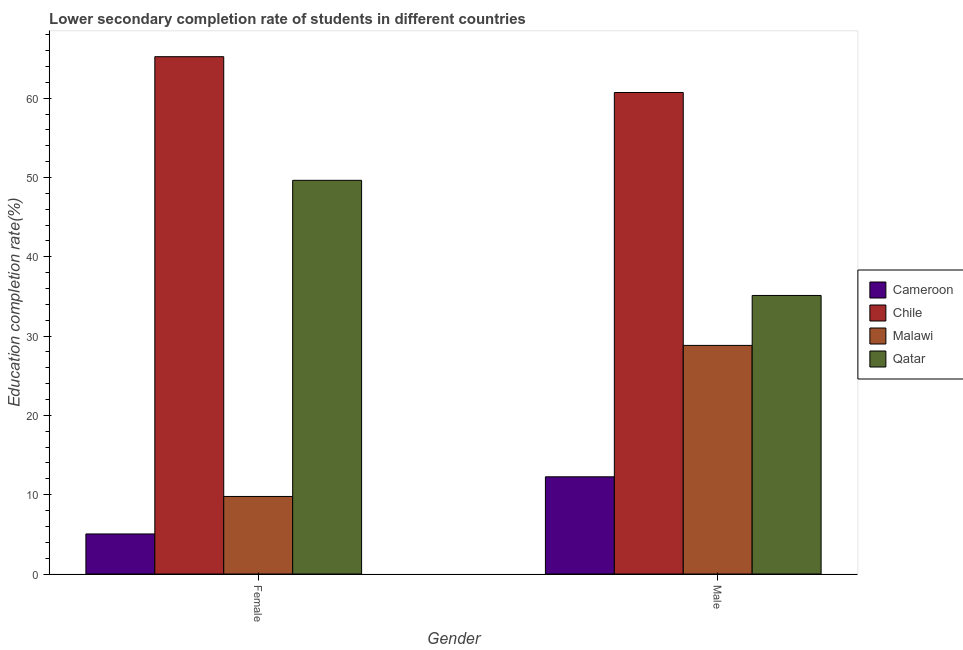Are the number of bars per tick equal to the number of legend labels?
Offer a terse response. Yes. Are the number of bars on each tick of the X-axis equal?
Ensure brevity in your answer.  Yes. How many bars are there on the 1st tick from the right?
Offer a very short reply. 4. What is the education completion rate of female students in Qatar?
Your answer should be compact. 49.64. Across all countries, what is the maximum education completion rate of female students?
Your answer should be very brief. 65.23. Across all countries, what is the minimum education completion rate of male students?
Ensure brevity in your answer.  12.26. In which country was the education completion rate of male students maximum?
Keep it short and to the point. Chile. In which country was the education completion rate of female students minimum?
Provide a succinct answer. Cameroon. What is the total education completion rate of male students in the graph?
Give a very brief answer. 136.91. What is the difference between the education completion rate of female students in Cameroon and that in Qatar?
Make the answer very short. -44.59. What is the difference between the education completion rate of male students in Malawi and the education completion rate of female students in Cameroon?
Ensure brevity in your answer.  23.77. What is the average education completion rate of male students per country?
Your answer should be very brief. 34.23. What is the difference between the education completion rate of male students and education completion rate of female students in Malawi?
Make the answer very short. 19.05. In how many countries, is the education completion rate of female students greater than 22 %?
Provide a short and direct response. 2. What is the ratio of the education completion rate of male students in Qatar to that in Cameroon?
Ensure brevity in your answer.  2.87. Is the education completion rate of female students in Malawi less than that in Qatar?
Your answer should be compact. Yes. What does the 4th bar from the left in Female represents?
Offer a very short reply. Qatar. What does the 3rd bar from the right in Female represents?
Provide a succinct answer. Chile. How many bars are there?
Make the answer very short. 8. Are all the bars in the graph horizontal?
Provide a succinct answer. No. Does the graph contain any zero values?
Ensure brevity in your answer.  No. Does the graph contain grids?
Your answer should be very brief. No. Where does the legend appear in the graph?
Your response must be concise. Center right. What is the title of the graph?
Provide a succinct answer. Lower secondary completion rate of students in different countries. What is the label or title of the Y-axis?
Make the answer very short. Education completion rate(%). What is the Education completion rate(%) of Cameroon in Female?
Give a very brief answer. 5.05. What is the Education completion rate(%) in Chile in Female?
Your answer should be compact. 65.23. What is the Education completion rate(%) in Malawi in Female?
Provide a short and direct response. 9.78. What is the Education completion rate(%) of Qatar in Female?
Your response must be concise. 49.64. What is the Education completion rate(%) in Cameroon in Male?
Make the answer very short. 12.26. What is the Education completion rate(%) of Chile in Male?
Make the answer very short. 60.71. What is the Education completion rate(%) in Malawi in Male?
Make the answer very short. 28.82. What is the Education completion rate(%) of Qatar in Male?
Offer a terse response. 35.12. Across all Gender, what is the maximum Education completion rate(%) in Cameroon?
Give a very brief answer. 12.26. Across all Gender, what is the maximum Education completion rate(%) in Chile?
Your answer should be very brief. 65.23. Across all Gender, what is the maximum Education completion rate(%) in Malawi?
Provide a succinct answer. 28.82. Across all Gender, what is the maximum Education completion rate(%) of Qatar?
Provide a short and direct response. 49.64. Across all Gender, what is the minimum Education completion rate(%) of Cameroon?
Offer a very short reply. 5.05. Across all Gender, what is the minimum Education completion rate(%) of Chile?
Your answer should be compact. 60.71. Across all Gender, what is the minimum Education completion rate(%) of Malawi?
Your response must be concise. 9.78. Across all Gender, what is the minimum Education completion rate(%) in Qatar?
Your answer should be compact. 35.12. What is the total Education completion rate(%) of Cameroon in the graph?
Offer a terse response. 17.31. What is the total Education completion rate(%) of Chile in the graph?
Your answer should be compact. 125.94. What is the total Education completion rate(%) in Malawi in the graph?
Keep it short and to the point. 38.6. What is the total Education completion rate(%) in Qatar in the graph?
Your answer should be compact. 84.76. What is the difference between the Education completion rate(%) of Cameroon in Female and that in Male?
Your answer should be very brief. -7.21. What is the difference between the Education completion rate(%) in Chile in Female and that in Male?
Offer a very short reply. 4.52. What is the difference between the Education completion rate(%) of Malawi in Female and that in Male?
Offer a very short reply. -19.05. What is the difference between the Education completion rate(%) of Qatar in Female and that in Male?
Offer a terse response. 14.52. What is the difference between the Education completion rate(%) of Cameroon in Female and the Education completion rate(%) of Chile in Male?
Your response must be concise. -55.66. What is the difference between the Education completion rate(%) in Cameroon in Female and the Education completion rate(%) in Malawi in Male?
Your answer should be very brief. -23.77. What is the difference between the Education completion rate(%) of Cameroon in Female and the Education completion rate(%) of Qatar in Male?
Ensure brevity in your answer.  -30.07. What is the difference between the Education completion rate(%) of Chile in Female and the Education completion rate(%) of Malawi in Male?
Give a very brief answer. 36.4. What is the difference between the Education completion rate(%) of Chile in Female and the Education completion rate(%) of Qatar in Male?
Make the answer very short. 30.11. What is the difference between the Education completion rate(%) in Malawi in Female and the Education completion rate(%) in Qatar in Male?
Provide a succinct answer. -25.34. What is the average Education completion rate(%) in Cameroon per Gender?
Provide a short and direct response. 8.65. What is the average Education completion rate(%) in Chile per Gender?
Offer a terse response. 62.97. What is the average Education completion rate(%) of Malawi per Gender?
Give a very brief answer. 19.3. What is the average Education completion rate(%) of Qatar per Gender?
Ensure brevity in your answer.  42.38. What is the difference between the Education completion rate(%) of Cameroon and Education completion rate(%) of Chile in Female?
Keep it short and to the point. -60.18. What is the difference between the Education completion rate(%) of Cameroon and Education completion rate(%) of Malawi in Female?
Make the answer very short. -4.73. What is the difference between the Education completion rate(%) of Cameroon and Education completion rate(%) of Qatar in Female?
Provide a succinct answer. -44.59. What is the difference between the Education completion rate(%) of Chile and Education completion rate(%) of Malawi in Female?
Provide a succinct answer. 55.45. What is the difference between the Education completion rate(%) of Chile and Education completion rate(%) of Qatar in Female?
Keep it short and to the point. 15.59. What is the difference between the Education completion rate(%) of Malawi and Education completion rate(%) of Qatar in Female?
Provide a succinct answer. -39.86. What is the difference between the Education completion rate(%) in Cameroon and Education completion rate(%) in Chile in Male?
Provide a short and direct response. -48.45. What is the difference between the Education completion rate(%) in Cameroon and Education completion rate(%) in Malawi in Male?
Provide a short and direct response. -16.57. What is the difference between the Education completion rate(%) in Cameroon and Education completion rate(%) in Qatar in Male?
Your answer should be very brief. -22.87. What is the difference between the Education completion rate(%) of Chile and Education completion rate(%) of Malawi in Male?
Make the answer very short. 31.89. What is the difference between the Education completion rate(%) in Chile and Education completion rate(%) in Qatar in Male?
Give a very brief answer. 25.59. What is the difference between the Education completion rate(%) in Malawi and Education completion rate(%) in Qatar in Male?
Provide a short and direct response. -6.3. What is the ratio of the Education completion rate(%) of Cameroon in Female to that in Male?
Your answer should be compact. 0.41. What is the ratio of the Education completion rate(%) in Chile in Female to that in Male?
Ensure brevity in your answer.  1.07. What is the ratio of the Education completion rate(%) in Malawi in Female to that in Male?
Your response must be concise. 0.34. What is the ratio of the Education completion rate(%) in Qatar in Female to that in Male?
Make the answer very short. 1.41. What is the difference between the highest and the second highest Education completion rate(%) of Cameroon?
Your answer should be compact. 7.21. What is the difference between the highest and the second highest Education completion rate(%) of Chile?
Offer a very short reply. 4.52. What is the difference between the highest and the second highest Education completion rate(%) of Malawi?
Make the answer very short. 19.05. What is the difference between the highest and the second highest Education completion rate(%) in Qatar?
Ensure brevity in your answer.  14.52. What is the difference between the highest and the lowest Education completion rate(%) in Cameroon?
Offer a very short reply. 7.21. What is the difference between the highest and the lowest Education completion rate(%) in Chile?
Offer a terse response. 4.52. What is the difference between the highest and the lowest Education completion rate(%) in Malawi?
Make the answer very short. 19.05. What is the difference between the highest and the lowest Education completion rate(%) in Qatar?
Offer a very short reply. 14.52. 